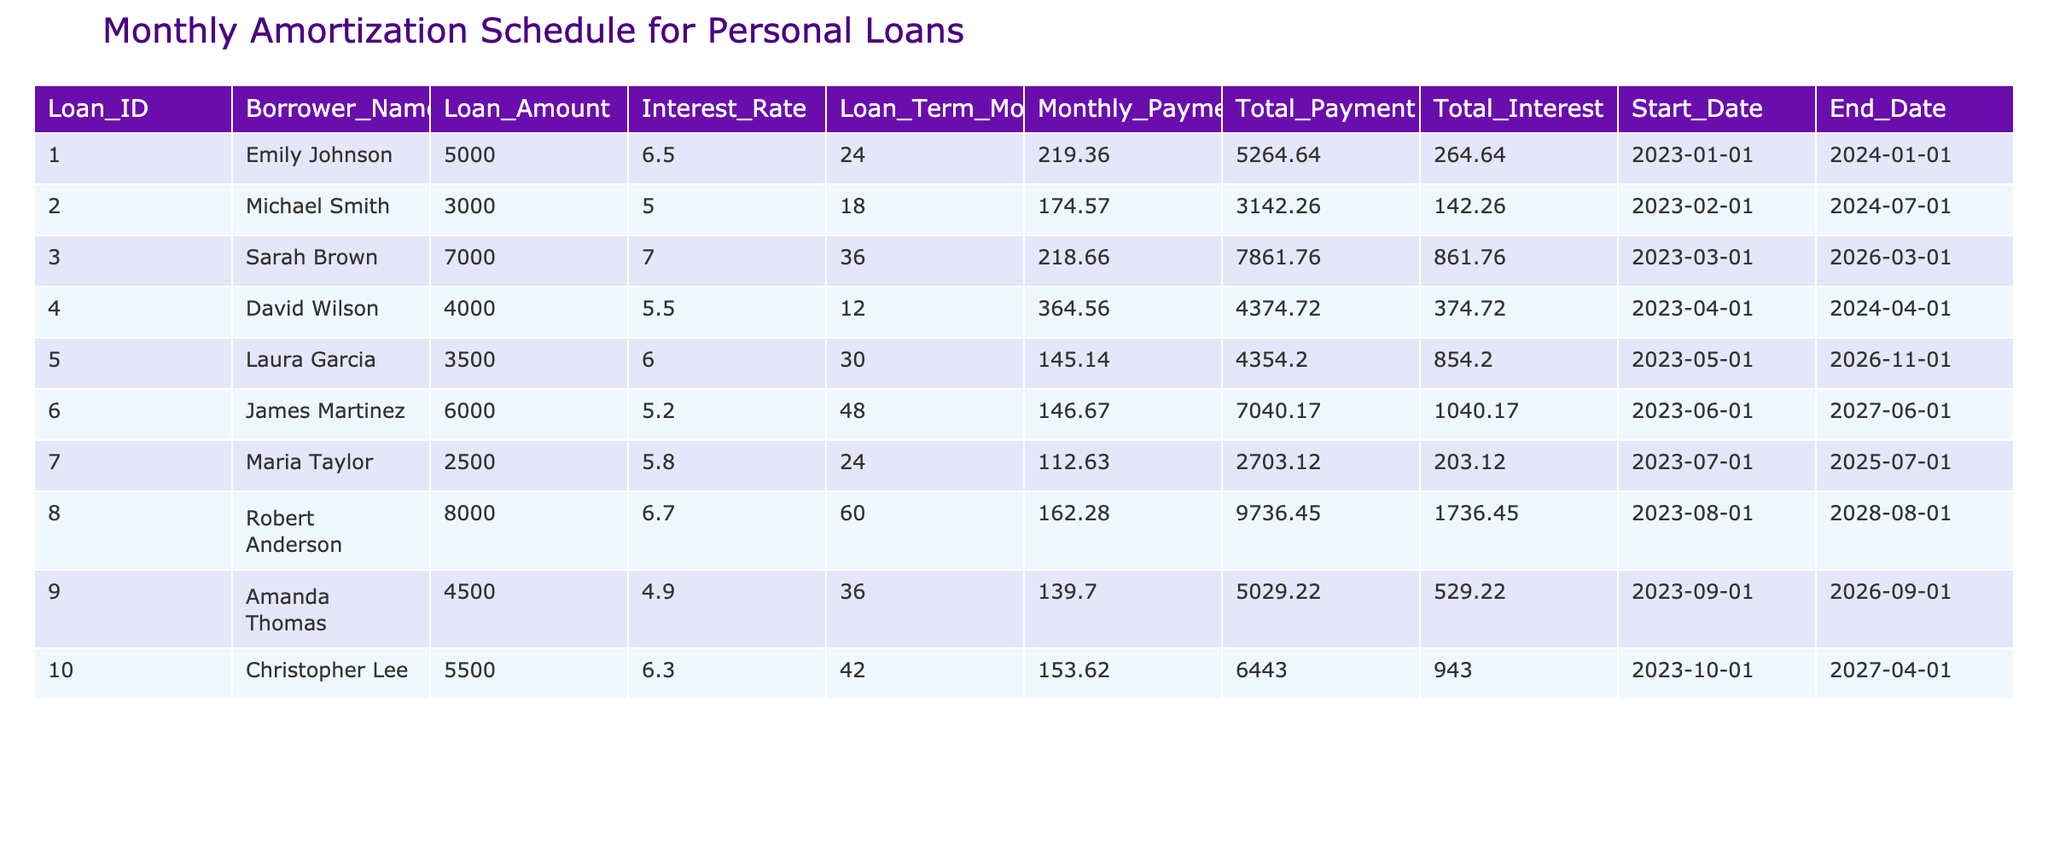What is the highest loan amount in the table? The table provides the loan amounts for each borrower. By comparing these amounts, it can be seen that the highest loan amount is for Robert Anderson, which is 8000.
Answer: 8000 What was Emily Johnson's total interest paid? Referring to the table, the total interest paid by Emily Johnson is directly listed as 264.64.
Answer: 264.64 Is the loan term for Michael Smith longer than that for David Wilson? Michael Smith’s loan term is 18 months while David Wilson’s loan term is 12 months. Since 18 is greater than 12, the answer is yes.
Answer: Yes What is the average monthly payment of all borrowers? To find the average, sum all the monthly payments: 219.36 + 174.57 + 218.66 + 364.56 + 145.14 + 146.67 + 112.63 + 162.28 + 139.70 + 153.62 = 1, 449.89. There are 10 borrowers, so the average is 1,449.89 / 10 = 144.99.
Answer: 144.99 Which borrower has the lowest interest rate on their loan and what is that rate? By reviewing the interest rates in the table, the lowest rate is 4.9% for Amanda Thomas.
Answer: 4.9% What is the total payment made by Laura Garcia? The table lists Laura Garcia's total payment as 4354.20. Thus, she is projected to pay this amount over the life of her loan.
Answer: 4354.20 How many borrowers have a loan term longer than 36 months? Referring to the table, Sarah Brown has a loan term of 36 months, and both James Martinez and Robert Anderson have loan terms of 48 and 60 months, respectively. Therefore, three borrowers have loan terms longer than 36 months.
Answer: 3 What is the difference in total payments between Sarah Brown and Christopher Lee? Looking at the total payments, Sarah Brown has a total payment of 7861.76 and Christopher Lee has 6443.00. The difference is calculated as 7861.76 - 6443.00, which equals 1418.76.
Answer: 1418.76 Does any borrower have a loan amount less than 3000? Checking the loan amounts, the lowest loan amount in the table is 2500 for Maria Taylor, which is indeed less than 3000. Thus, the answer is yes.
Answer: Yes How much total interest will James Martinez pay over the course of his loan? The table indicates that James Martinez will pay a total interest of 1040.17 over the loan term.
Answer: 1040.17 